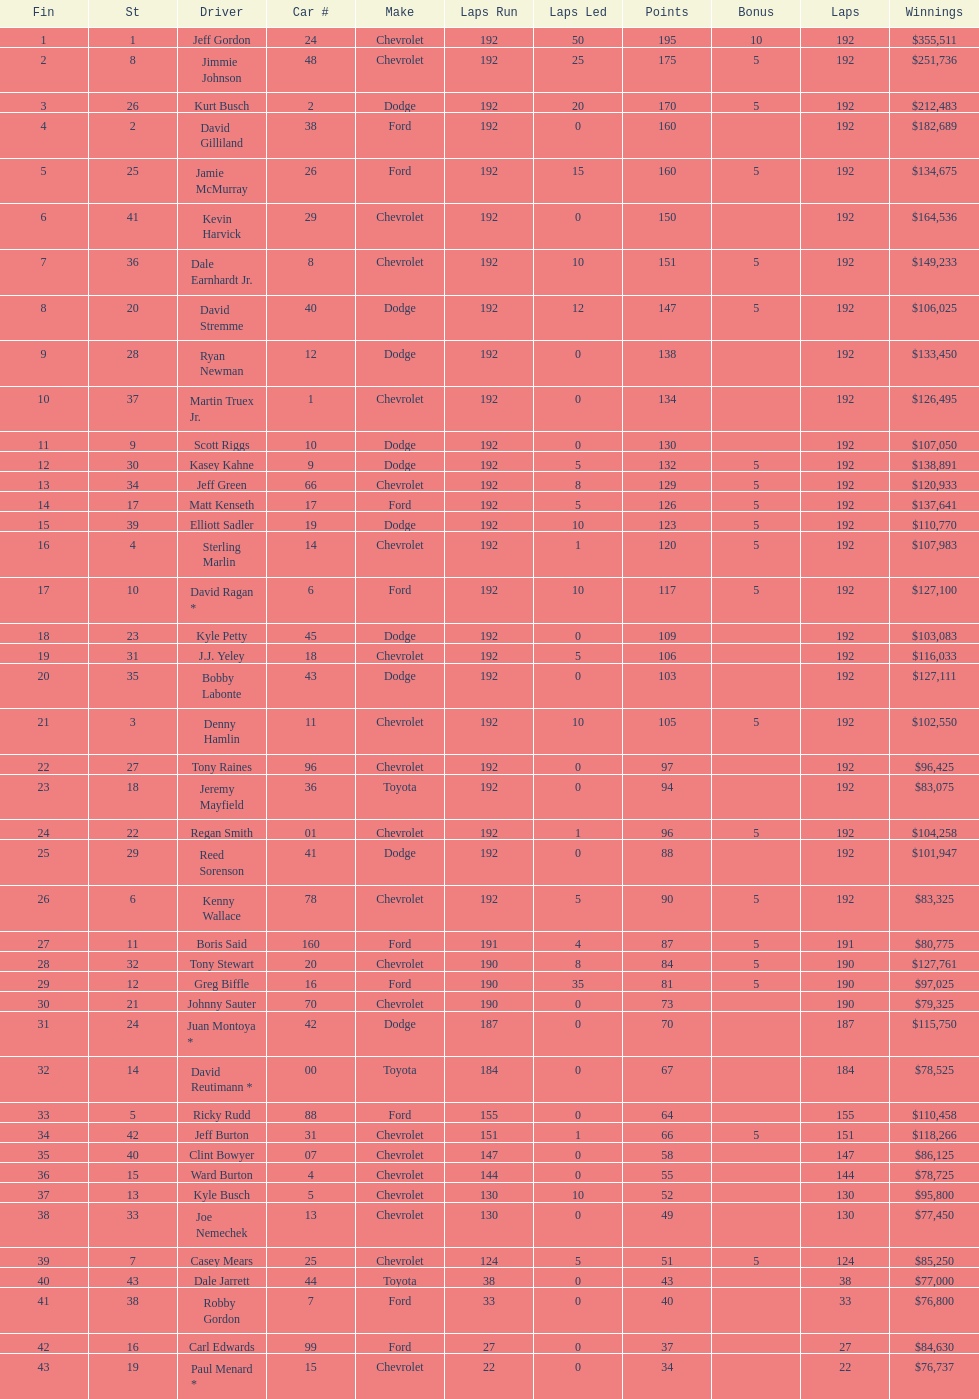How many race car drivers out of the 43 listed drove toyotas? 3. 